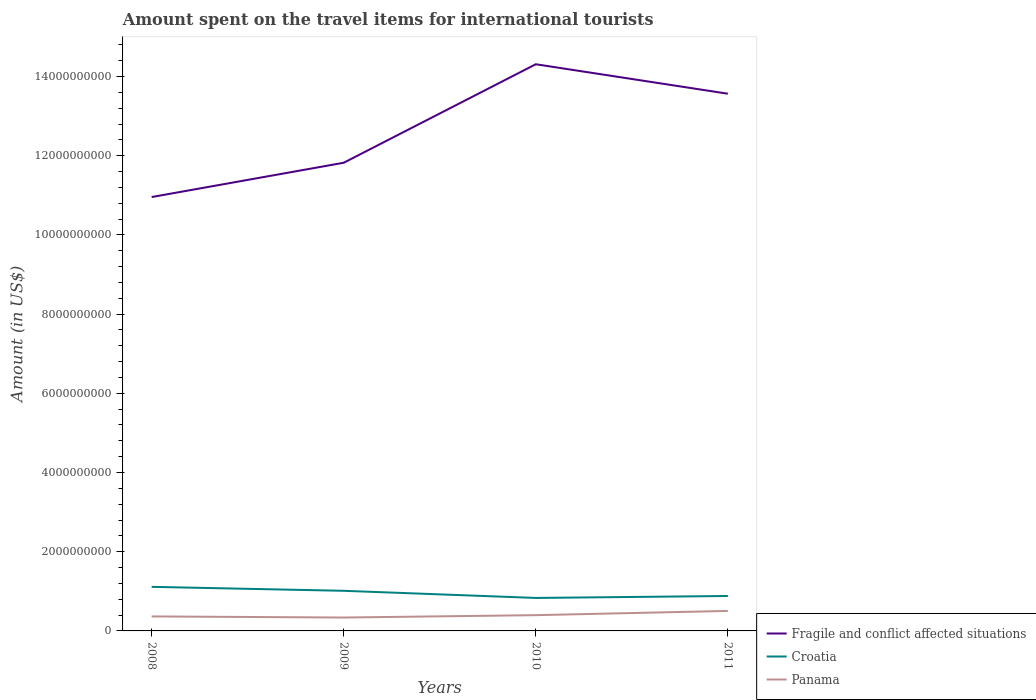How many different coloured lines are there?
Your answer should be compact. 3. Does the line corresponding to Croatia intersect with the line corresponding to Panama?
Ensure brevity in your answer.  No. Is the number of lines equal to the number of legend labels?
Ensure brevity in your answer.  Yes. Across all years, what is the maximum amount spent on the travel items for international tourists in Croatia?
Your answer should be compact. 8.33e+08. In which year was the amount spent on the travel items for international tourists in Croatia maximum?
Provide a succinct answer. 2010. What is the total amount spent on the travel items for international tourists in Croatia in the graph?
Ensure brevity in your answer.  1.31e+08. What is the difference between the highest and the second highest amount spent on the travel items for international tourists in Fragile and conflict affected situations?
Ensure brevity in your answer.  3.35e+09. What is the difference between the highest and the lowest amount spent on the travel items for international tourists in Croatia?
Your answer should be compact. 2. How many years are there in the graph?
Provide a succinct answer. 4. What is the difference between two consecutive major ticks on the Y-axis?
Make the answer very short. 2.00e+09. Does the graph contain grids?
Provide a succinct answer. No. How are the legend labels stacked?
Offer a terse response. Vertical. What is the title of the graph?
Offer a very short reply. Amount spent on the travel items for international tourists. Does "Lesotho" appear as one of the legend labels in the graph?
Provide a short and direct response. No. What is the label or title of the Y-axis?
Your answer should be very brief. Amount (in US$). What is the Amount (in US$) in Fragile and conflict affected situations in 2008?
Your answer should be compact. 1.10e+1. What is the Amount (in US$) in Croatia in 2008?
Provide a succinct answer. 1.11e+09. What is the Amount (in US$) of Panama in 2008?
Your answer should be compact. 3.66e+08. What is the Amount (in US$) of Fragile and conflict affected situations in 2009?
Give a very brief answer. 1.18e+1. What is the Amount (in US$) in Croatia in 2009?
Provide a succinct answer. 1.01e+09. What is the Amount (in US$) of Panama in 2009?
Provide a short and direct response. 3.38e+08. What is the Amount (in US$) in Fragile and conflict affected situations in 2010?
Make the answer very short. 1.43e+1. What is the Amount (in US$) in Croatia in 2010?
Your answer should be compact. 8.33e+08. What is the Amount (in US$) of Panama in 2010?
Offer a terse response. 3.98e+08. What is the Amount (in US$) in Fragile and conflict affected situations in 2011?
Your answer should be very brief. 1.36e+1. What is the Amount (in US$) in Croatia in 2011?
Your answer should be compact. 8.82e+08. What is the Amount (in US$) in Panama in 2011?
Make the answer very short. 5.05e+08. Across all years, what is the maximum Amount (in US$) in Fragile and conflict affected situations?
Make the answer very short. 1.43e+1. Across all years, what is the maximum Amount (in US$) of Croatia?
Offer a very short reply. 1.11e+09. Across all years, what is the maximum Amount (in US$) of Panama?
Offer a terse response. 5.05e+08. Across all years, what is the minimum Amount (in US$) of Fragile and conflict affected situations?
Your answer should be compact. 1.10e+1. Across all years, what is the minimum Amount (in US$) in Croatia?
Offer a very short reply. 8.33e+08. Across all years, what is the minimum Amount (in US$) in Panama?
Keep it short and to the point. 3.38e+08. What is the total Amount (in US$) of Fragile and conflict affected situations in the graph?
Give a very brief answer. 5.07e+1. What is the total Amount (in US$) in Croatia in the graph?
Provide a succinct answer. 3.84e+09. What is the total Amount (in US$) in Panama in the graph?
Ensure brevity in your answer.  1.61e+09. What is the difference between the Amount (in US$) in Fragile and conflict affected situations in 2008 and that in 2009?
Make the answer very short. -8.66e+08. What is the difference between the Amount (in US$) in Panama in 2008 and that in 2009?
Offer a very short reply. 2.80e+07. What is the difference between the Amount (in US$) in Fragile and conflict affected situations in 2008 and that in 2010?
Make the answer very short. -3.35e+09. What is the difference between the Amount (in US$) of Croatia in 2008 and that in 2010?
Your answer should be very brief. 2.80e+08. What is the difference between the Amount (in US$) of Panama in 2008 and that in 2010?
Keep it short and to the point. -3.20e+07. What is the difference between the Amount (in US$) in Fragile and conflict affected situations in 2008 and that in 2011?
Your answer should be very brief. -2.61e+09. What is the difference between the Amount (in US$) of Croatia in 2008 and that in 2011?
Your answer should be very brief. 2.31e+08. What is the difference between the Amount (in US$) in Panama in 2008 and that in 2011?
Offer a terse response. -1.39e+08. What is the difference between the Amount (in US$) of Fragile and conflict affected situations in 2009 and that in 2010?
Keep it short and to the point. -2.49e+09. What is the difference between the Amount (in US$) in Croatia in 2009 and that in 2010?
Keep it short and to the point. 1.80e+08. What is the difference between the Amount (in US$) in Panama in 2009 and that in 2010?
Your answer should be very brief. -6.00e+07. What is the difference between the Amount (in US$) in Fragile and conflict affected situations in 2009 and that in 2011?
Make the answer very short. -1.74e+09. What is the difference between the Amount (in US$) of Croatia in 2009 and that in 2011?
Offer a terse response. 1.31e+08. What is the difference between the Amount (in US$) in Panama in 2009 and that in 2011?
Your answer should be very brief. -1.67e+08. What is the difference between the Amount (in US$) in Fragile and conflict affected situations in 2010 and that in 2011?
Provide a succinct answer. 7.44e+08. What is the difference between the Amount (in US$) of Croatia in 2010 and that in 2011?
Give a very brief answer. -4.90e+07. What is the difference between the Amount (in US$) in Panama in 2010 and that in 2011?
Give a very brief answer. -1.07e+08. What is the difference between the Amount (in US$) of Fragile and conflict affected situations in 2008 and the Amount (in US$) of Croatia in 2009?
Your answer should be very brief. 9.94e+09. What is the difference between the Amount (in US$) in Fragile and conflict affected situations in 2008 and the Amount (in US$) in Panama in 2009?
Ensure brevity in your answer.  1.06e+1. What is the difference between the Amount (in US$) of Croatia in 2008 and the Amount (in US$) of Panama in 2009?
Make the answer very short. 7.75e+08. What is the difference between the Amount (in US$) in Fragile and conflict affected situations in 2008 and the Amount (in US$) in Croatia in 2010?
Provide a succinct answer. 1.01e+1. What is the difference between the Amount (in US$) of Fragile and conflict affected situations in 2008 and the Amount (in US$) of Panama in 2010?
Offer a terse response. 1.06e+1. What is the difference between the Amount (in US$) in Croatia in 2008 and the Amount (in US$) in Panama in 2010?
Give a very brief answer. 7.15e+08. What is the difference between the Amount (in US$) in Fragile and conflict affected situations in 2008 and the Amount (in US$) in Croatia in 2011?
Offer a terse response. 1.01e+1. What is the difference between the Amount (in US$) of Fragile and conflict affected situations in 2008 and the Amount (in US$) of Panama in 2011?
Make the answer very short. 1.05e+1. What is the difference between the Amount (in US$) in Croatia in 2008 and the Amount (in US$) in Panama in 2011?
Give a very brief answer. 6.08e+08. What is the difference between the Amount (in US$) of Fragile and conflict affected situations in 2009 and the Amount (in US$) of Croatia in 2010?
Your response must be concise. 1.10e+1. What is the difference between the Amount (in US$) in Fragile and conflict affected situations in 2009 and the Amount (in US$) in Panama in 2010?
Give a very brief answer. 1.14e+1. What is the difference between the Amount (in US$) in Croatia in 2009 and the Amount (in US$) in Panama in 2010?
Your answer should be compact. 6.15e+08. What is the difference between the Amount (in US$) of Fragile and conflict affected situations in 2009 and the Amount (in US$) of Croatia in 2011?
Your answer should be very brief. 1.09e+1. What is the difference between the Amount (in US$) of Fragile and conflict affected situations in 2009 and the Amount (in US$) of Panama in 2011?
Your answer should be very brief. 1.13e+1. What is the difference between the Amount (in US$) of Croatia in 2009 and the Amount (in US$) of Panama in 2011?
Offer a very short reply. 5.08e+08. What is the difference between the Amount (in US$) of Fragile and conflict affected situations in 2010 and the Amount (in US$) of Croatia in 2011?
Provide a short and direct response. 1.34e+1. What is the difference between the Amount (in US$) of Fragile and conflict affected situations in 2010 and the Amount (in US$) of Panama in 2011?
Provide a succinct answer. 1.38e+1. What is the difference between the Amount (in US$) in Croatia in 2010 and the Amount (in US$) in Panama in 2011?
Provide a succinct answer. 3.28e+08. What is the average Amount (in US$) in Fragile and conflict affected situations per year?
Offer a very short reply. 1.27e+1. What is the average Amount (in US$) of Croatia per year?
Give a very brief answer. 9.60e+08. What is the average Amount (in US$) in Panama per year?
Ensure brevity in your answer.  4.02e+08. In the year 2008, what is the difference between the Amount (in US$) in Fragile and conflict affected situations and Amount (in US$) in Croatia?
Provide a short and direct response. 9.84e+09. In the year 2008, what is the difference between the Amount (in US$) of Fragile and conflict affected situations and Amount (in US$) of Panama?
Your response must be concise. 1.06e+1. In the year 2008, what is the difference between the Amount (in US$) of Croatia and Amount (in US$) of Panama?
Offer a very short reply. 7.47e+08. In the year 2009, what is the difference between the Amount (in US$) in Fragile and conflict affected situations and Amount (in US$) in Croatia?
Keep it short and to the point. 1.08e+1. In the year 2009, what is the difference between the Amount (in US$) in Fragile and conflict affected situations and Amount (in US$) in Panama?
Ensure brevity in your answer.  1.15e+1. In the year 2009, what is the difference between the Amount (in US$) of Croatia and Amount (in US$) of Panama?
Make the answer very short. 6.75e+08. In the year 2010, what is the difference between the Amount (in US$) in Fragile and conflict affected situations and Amount (in US$) in Croatia?
Offer a terse response. 1.35e+1. In the year 2010, what is the difference between the Amount (in US$) of Fragile and conflict affected situations and Amount (in US$) of Panama?
Keep it short and to the point. 1.39e+1. In the year 2010, what is the difference between the Amount (in US$) in Croatia and Amount (in US$) in Panama?
Ensure brevity in your answer.  4.35e+08. In the year 2011, what is the difference between the Amount (in US$) in Fragile and conflict affected situations and Amount (in US$) in Croatia?
Ensure brevity in your answer.  1.27e+1. In the year 2011, what is the difference between the Amount (in US$) in Fragile and conflict affected situations and Amount (in US$) in Panama?
Provide a succinct answer. 1.31e+1. In the year 2011, what is the difference between the Amount (in US$) in Croatia and Amount (in US$) in Panama?
Give a very brief answer. 3.77e+08. What is the ratio of the Amount (in US$) in Fragile and conflict affected situations in 2008 to that in 2009?
Provide a short and direct response. 0.93. What is the ratio of the Amount (in US$) of Croatia in 2008 to that in 2009?
Provide a short and direct response. 1.1. What is the ratio of the Amount (in US$) of Panama in 2008 to that in 2009?
Your answer should be very brief. 1.08. What is the ratio of the Amount (in US$) in Fragile and conflict affected situations in 2008 to that in 2010?
Give a very brief answer. 0.77. What is the ratio of the Amount (in US$) in Croatia in 2008 to that in 2010?
Provide a short and direct response. 1.34. What is the ratio of the Amount (in US$) in Panama in 2008 to that in 2010?
Your response must be concise. 0.92. What is the ratio of the Amount (in US$) in Fragile and conflict affected situations in 2008 to that in 2011?
Your answer should be very brief. 0.81. What is the ratio of the Amount (in US$) in Croatia in 2008 to that in 2011?
Your answer should be compact. 1.26. What is the ratio of the Amount (in US$) in Panama in 2008 to that in 2011?
Offer a very short reply. 0.72. What is the ratio of the Amount (in US$) of Fragile and conflict affected situations in 2009 to that in 2010?
Keep it short and to the point. 0.83. What is the ratio of the Amount (in US$) of Croatia in 2009 to that in 2010?
Give a very brief answer. 1.22. What is the ratio of the Amount (in US$) in Panama in 2009 to that in 2010?
Give a very brief answer. 0.85. What is the ratio of the Amount (in US$) of Fragile and conflict affected situations in 2009 to that in 2011?
Your response must be concise. 0.87. What is the ratio of the Amount (in US$) of Croatia in 2009 to that in 2011?
Ensure brevity in your answer.  1.15. What is the ratio of the Amount (in US$) in Panama in 2009 to that in 2011?
Your response must be concise. 0.67. What is the ratio of the Amount (in US$) of Fragile and conflict affected situations in 2010 to that in 2011?
Make the answer very short. 1.05. What is the ratio of the Amount (in US$) in Croatia in 2010 to that in 2011?
Your answer should be very brief. 0.94. What is the ratio of the Amount (in US$) in Panama in 2010 to that in 2011?
Offer a very short reply. 0.79. What is the difference between the highest and the second highest Amount (in US$) of Fragile and conflict affected situations?
Offer a terse response. 7.44e+08. What is the difference between the highest and the second highest Amount (in US$) in Croatia?
Your answer should be very brief. 1.00e+08. What is the difference between the highest and the second highest Amount (in US$) of Panama?
Your answer should be compact. 1.07e+08. What is the difference between the highest and the lowest Amount (in US$) of Fragile and conflict affected situations?
Give a very brief answer. 3.35e+09. What is the difference between the highest and the lowest Amount (in US$) in Croatia?
Offer a terse response. 2.80e+08. What is the difference between the highest and the lowest Amount (in US$) in Panama?
Make the answer very short. 1.67e+08. 